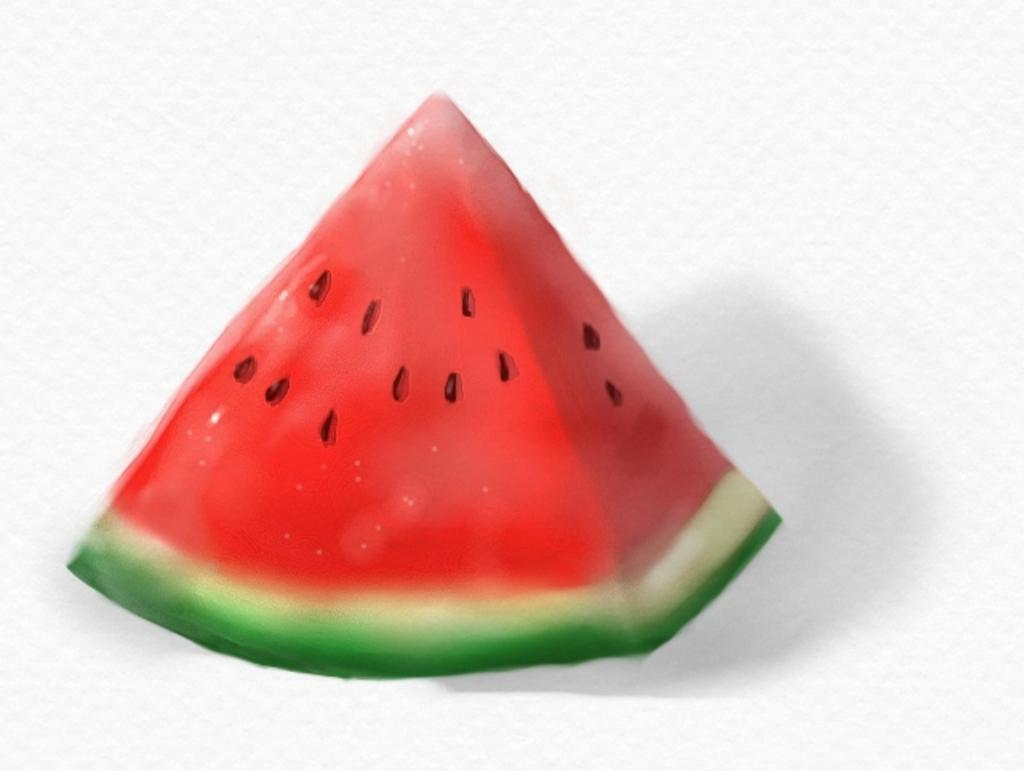What type of food is depicted in the animated picture in the image? The animated picture in the image contains a watermelon slice. What is the nature of the image, considering the presence of an animated picture? The image contains an animated picture of a watermelon slice. What type of reward can be seen at the seashore in the image? There is no reward or seashore present in the image; it contains an animated picture of a watermelon slice. 